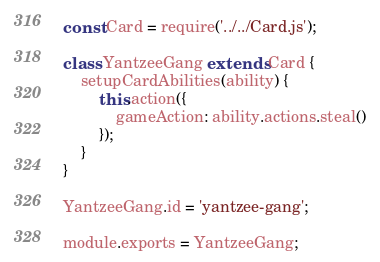Convert code to text. <code><loc_0><loc_0><loc_500><loc_500><_JavaScript_>const Card = require('../../Card.js');

class YantzeeGang extends Card {
    setupCardAbilities(ability) {
        this.action({
            gameAction: ability.actions.steal()
        });
    }
}

YantzeeGang.id = 'yantzee-gang';

module.exports = YantzeeGang;
</code> 